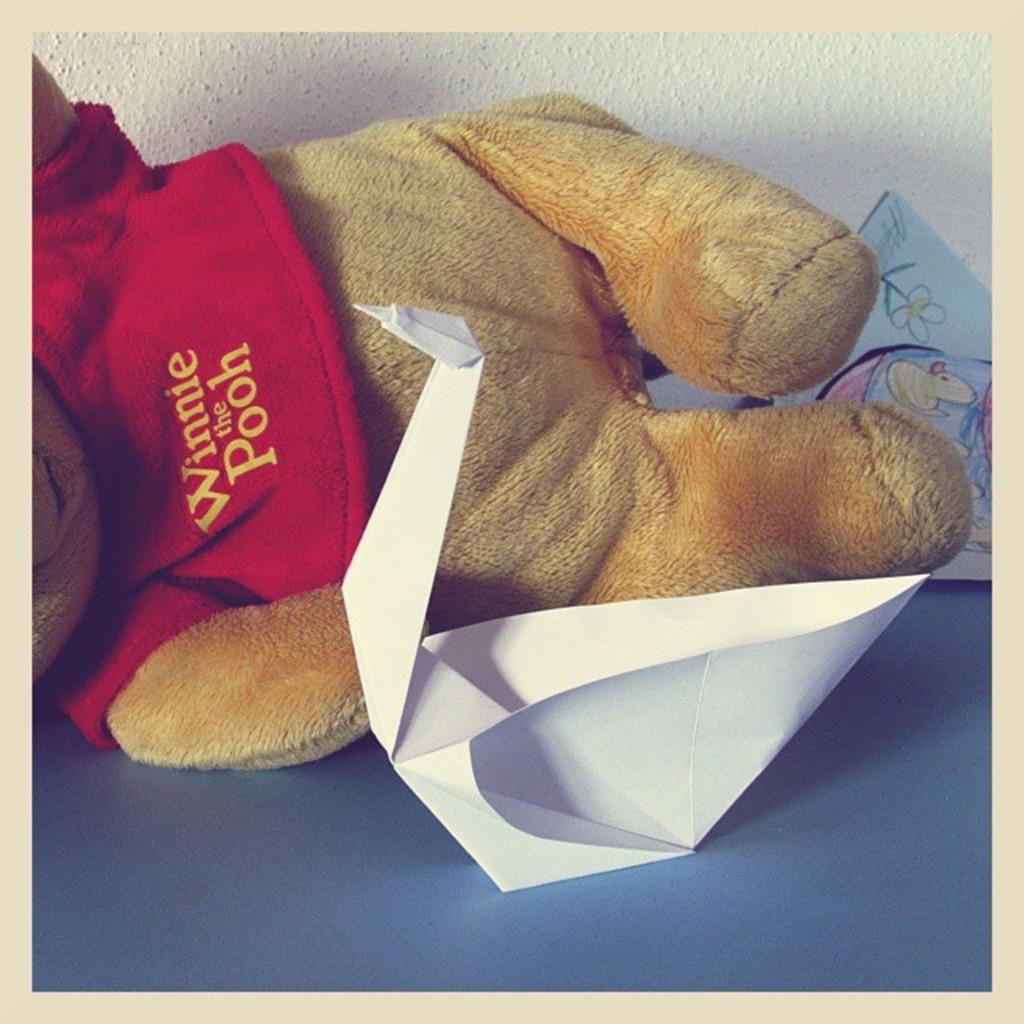What is the main subject of the image? The main subject of the image is a teddy bear. Where is the teddy bear located in the image? The teddy bear is on a platform in the image. What type of bead is used to decorate the teddy bear's eyes in the image? There are no beads present on the teddy bear in the image. 